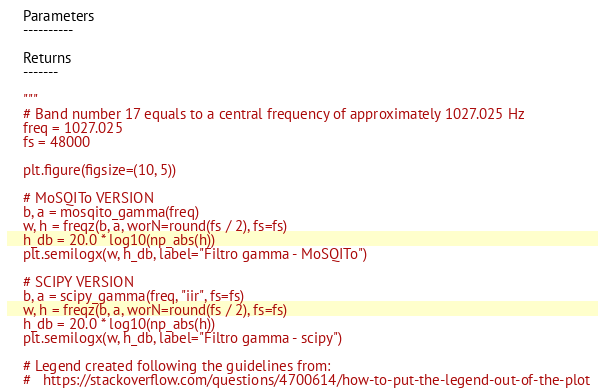<code> <loc_0><loc_0><loc_500><loc_500><_Python_>    Parameters
    ----------

    Returns
    -------

    """
    # Band number 17 equals to a central frequency of approximately 1027.025 Hz
    freq = 1027.025
    fs = 48000

    plt.figure(figsize=(10, 5))

    # MoSQITo VERSION
    b, a = mosqito_gamma(freq)
    w, h = freqz(b, a, worN=round(fs / 2), fs=fs)
    h_db = 20.0 * log10(np_abs(h))
    plt.semilogx(w, h_db, label="Filtro gamma - MoSQITo")

    # SCIPY VERSION
    b, a = scipy_gamma(freq, "iir", fs=fs)
    w, h = freqz(b, a, worN=round(fs / 2), fs=fs)
    h_db = 20.0 * log10(np_abs(h))
    plt.semilogx(w, h_db, label="Filtro gamma - scipy")

    # Legend created following the guidelines from:
    #   https://stackoverflow.com/questions/4700614/how-to-put-the-legend-out-of-the-plot</code> 